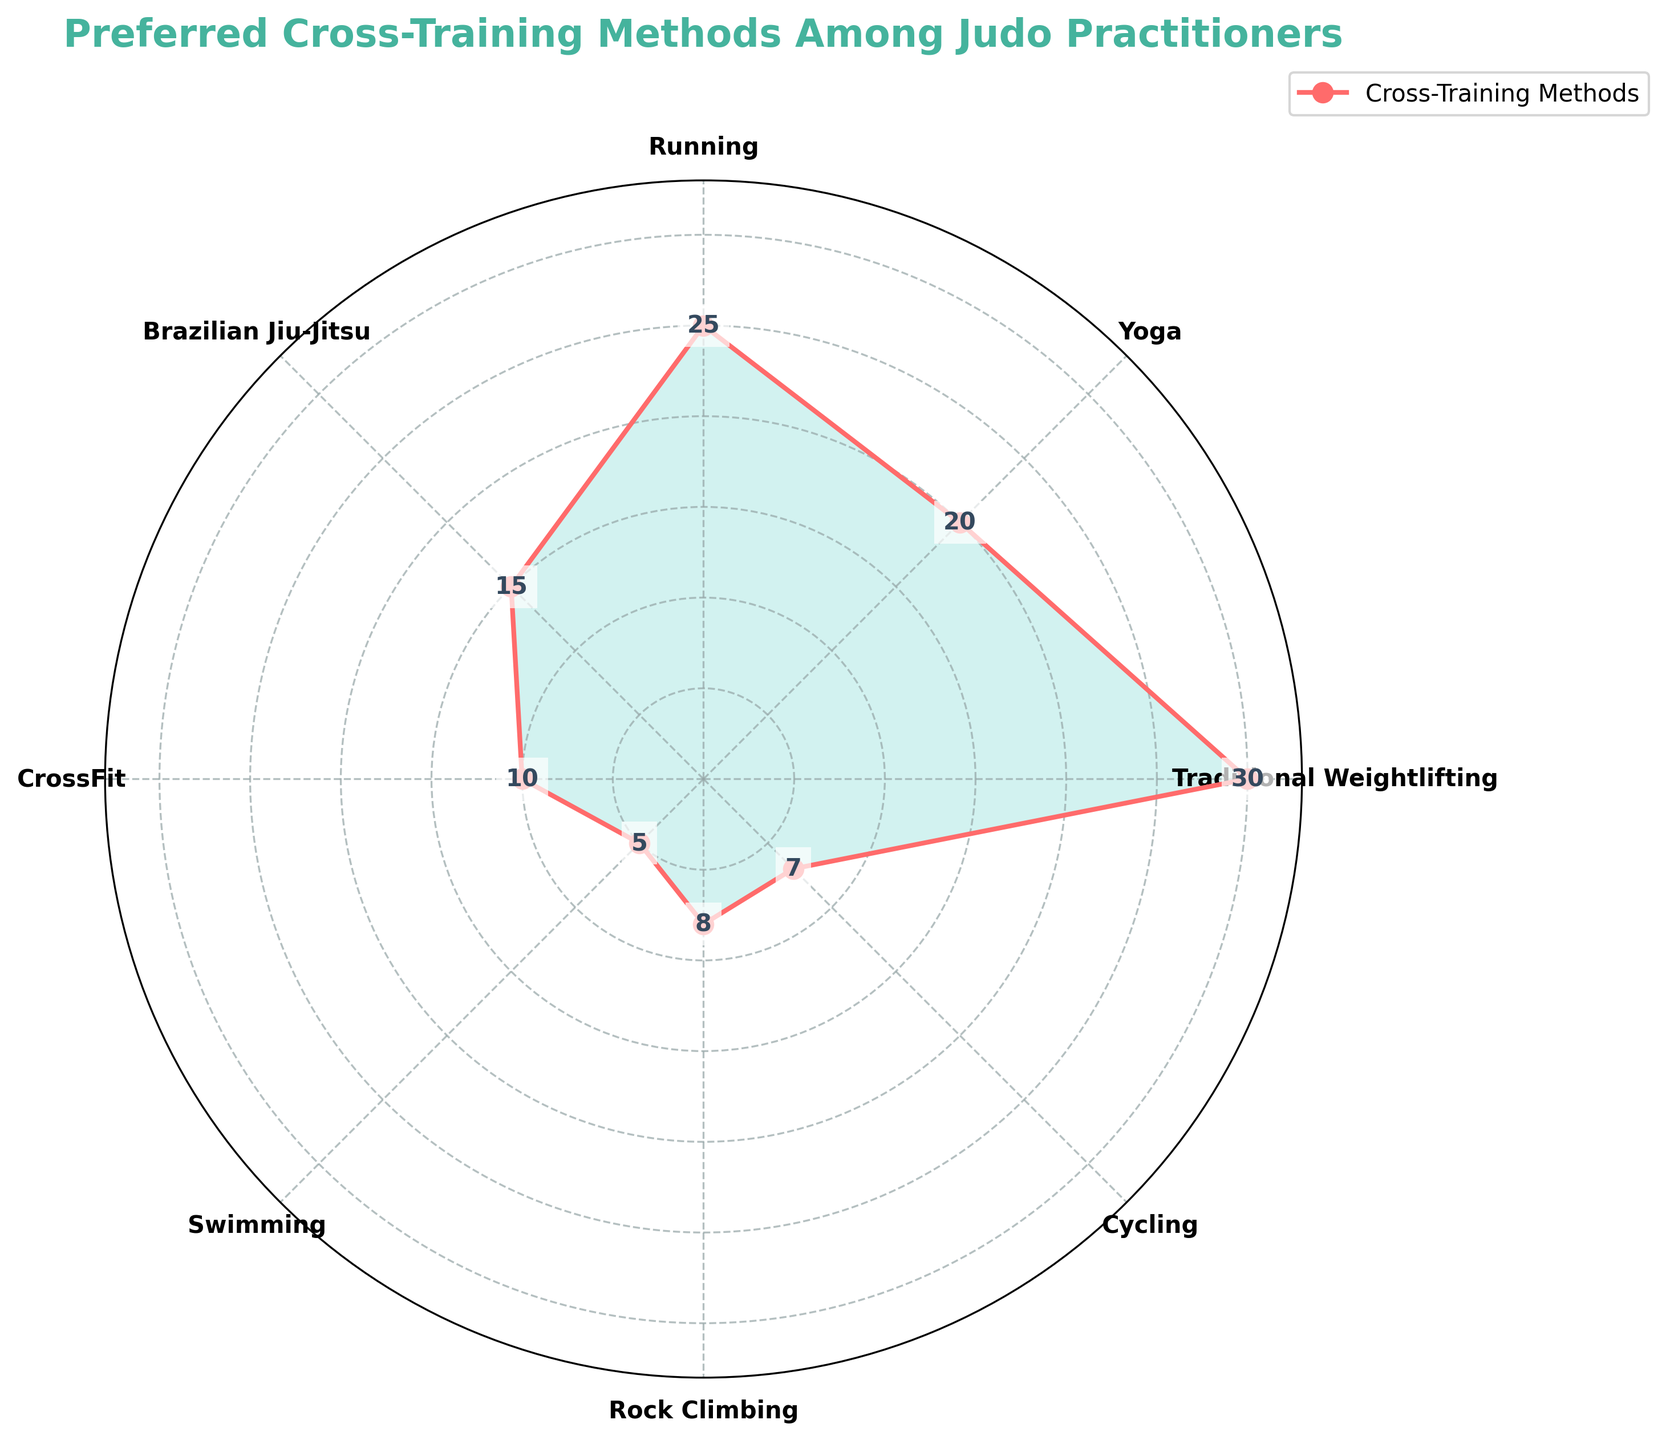What's the most preferred cross-training method among judo practitioners? The figure shows various cross-training methods with their corresponding values. Traditional Weightlifting has the highest value.
Answer: Traditional Weightlifting What's the least preferred cross-training method among judo practitioners? The figure shows that Swimming has the smallest value among all the methods listed.
Answer: Swimming What's the combined value of Yoga and Running? From the figure, the value for Yoga is 20 and for Running is 25. Their combined value is 20 + 25.
Answer: 45 How many cross-training methods have a value below 10? The figure lists multiple cross-training methods and their values. The methods with values below 10 are Swimming (5), Rock Climbing (8), and Cycling (7).
Answer: 3 Which cross-training method is more preferred: Brazilian Jiu-Jitsu or CrossFit? The figure shows that the value for Brazilian Jiu-Jitsu is 15, whereas for CrossFit, it is 10.
Answer: Brazilian Jiu-Jitsu By what margin is Traditional Weightlifting more preferred than CrossFit? From the figure, the value for Traditional Weightlifting is 30, and for CrossFit, it is 10. The margin is 30 - 10.
Answer: 20 Rank the top three cross-training methods based on their preference. The figure shows the values for each method. The top three methods according to their values are Traditional Weightlifting (30), Running (25), and Yoga (20).
Answer: Traditional Weightlifting, Running, Yoga What is the average value for all the cross-training methods listed? The figure provides the values: 30, 20, 25, 15, 10, 5, 8, 7. Sum them up to get 120, and divide by the number of methods, which is 8. So the average is 120/8.
Answer: 15 Which method has a preference value closest to the average preference value? First, calculate the average value as 15. Check the values: 30, 20, 25, 15, 10, 5, 8, 7. The closest value to 15 is 15 itself, which corresponds to Brazilian Jiu-Jitsu.
Answer: Brazilian Jiu-Jitsu How much more popular is Running compared to Swimming? The figure shows Running with a value of 25 and Swimming with 5. The difference is 25 - 5.
Answer: 20 